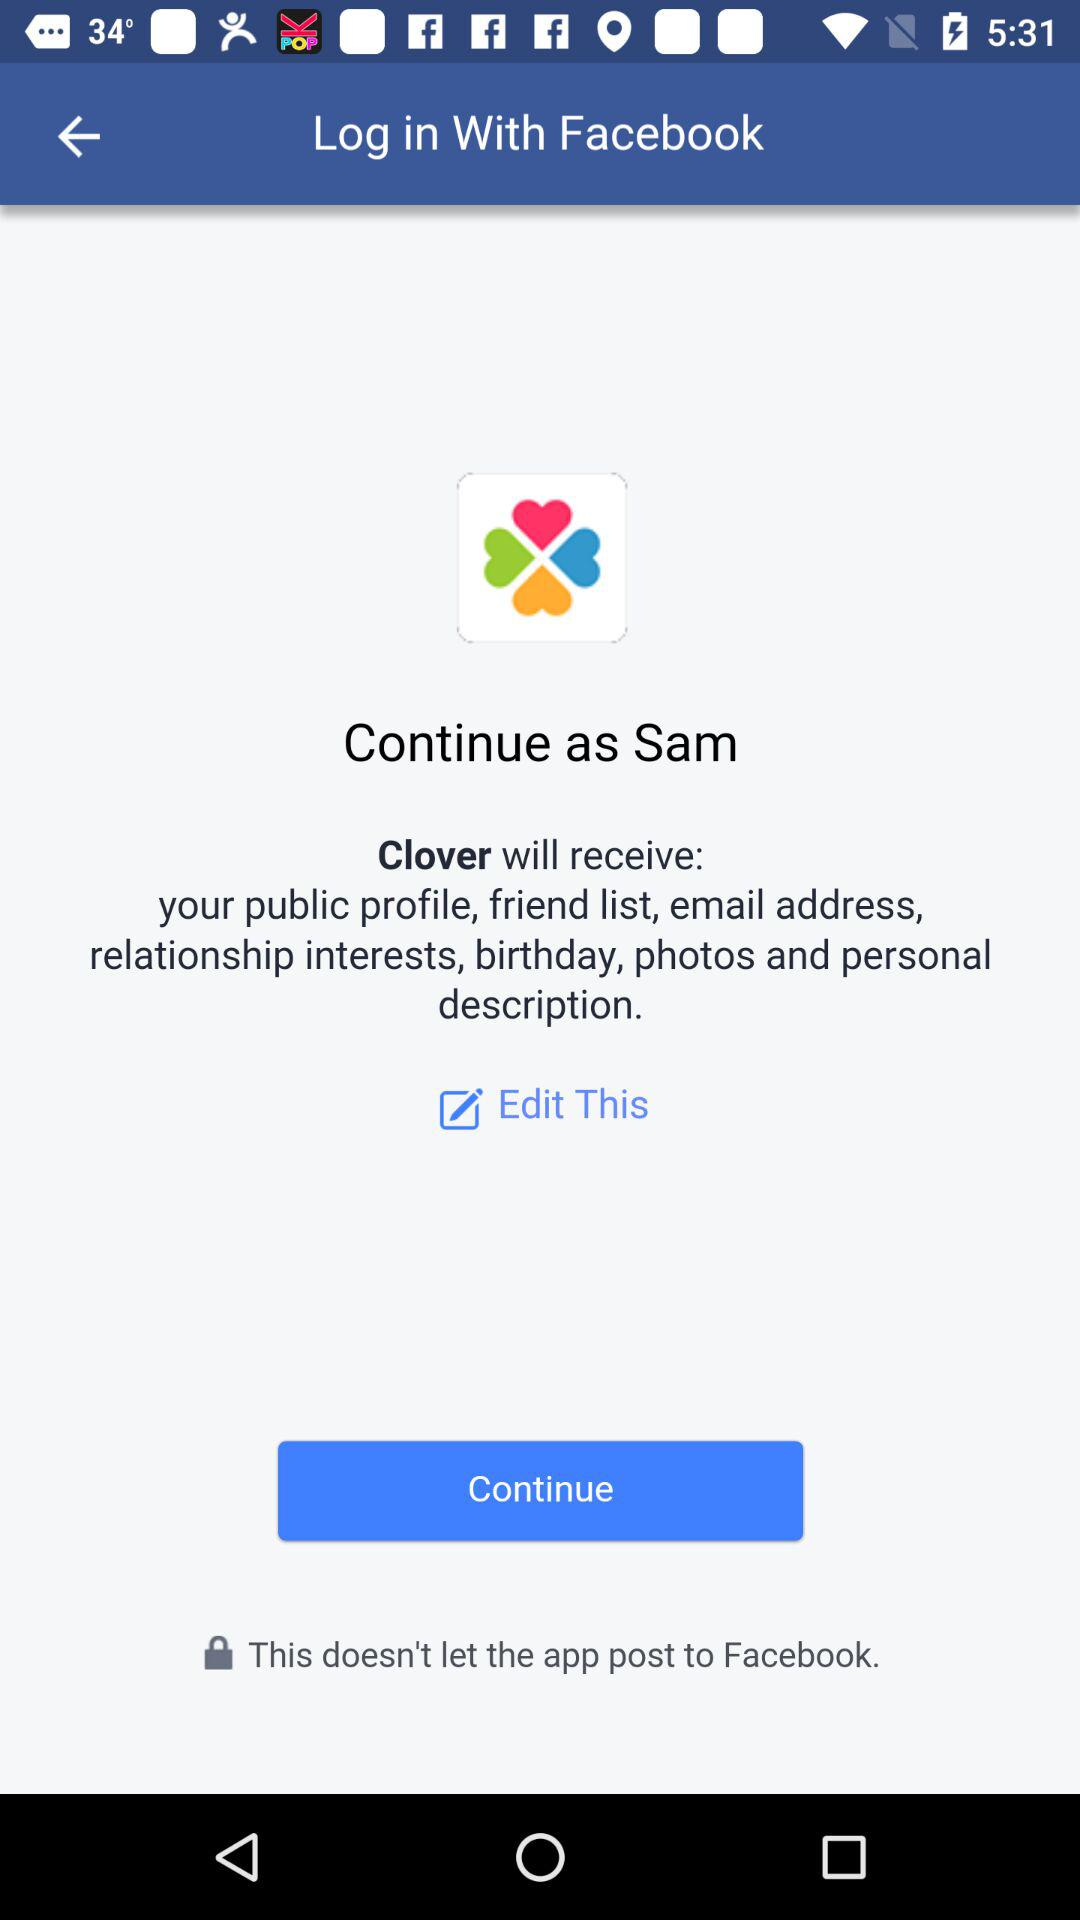What is the user name to continue the profile? The user name is Sam. 